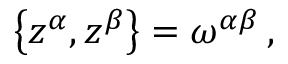Convert formula to latex. <formula><loc_0><loc_0><loc_500><loc_500>\begin{array} { r } { \left \{ z ^ { \alpha } , z ^ { \beta } \right \} = \omega ^ { \alpha \beta } \, , } \end{array}</formula> 